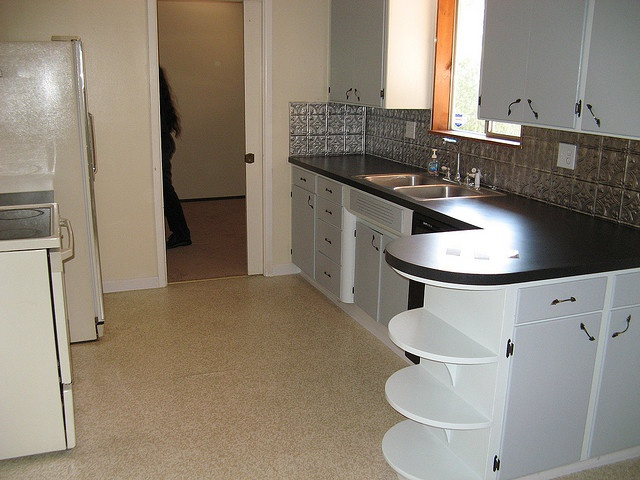Describe the objects in this image and their specific colors. I can see oven in gray, lightgray, and darkgray tones, refrigerator in gray, darkgray, and lightgray tones, people in gray, black, tan, and maroon tones, sink in gray and black tones, and sink in gray and black tones in this image. 